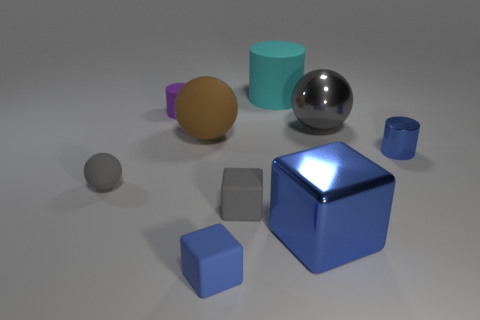Add 1 tiny gray matte blocks. How many objects exist? 10 Subtract all green cylinders. Subtract all green blocks. How many cylinders are left? 3 Subtract all balls. How many objects are left? 6 Add 5 blue metallic cubes. How many blue metallic cubes are left? 6 Add 3 rubber blocks. How many rubber blocks exist? 5 Subtract 0 gray cylinders. How many objects are left? 9 Subtract all blue metal blocks. Subtract all big gray things. How many objects are left? 7 